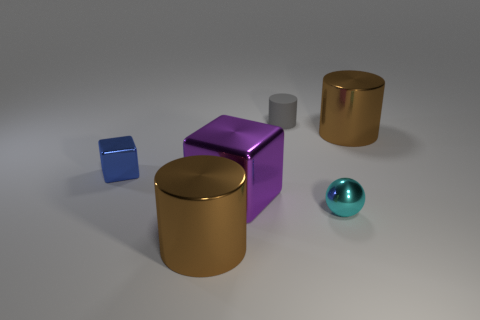Add 3 blue blocks. How many objects exist? 9 Subtract all tiny cylinders. How many cylinders are left? 2 Subtract 1 cubes. How many cubes are left? 1 Subtract all gray cylinders. How many cylinders are left? 2 Subtract all balls. How many objects are left? 5 Add 6 tiny gray shiny objects. How many tiny gray shiny objects exist? 6 Subtract 1 cyan balls. How many objects are left? 5 Subtract all brown spheres. Subtract all red cylinders. How many spheres are left? 1 Subtract all cyan cubes. How many purple spheres are left? 0 Subtract all large purple blocks. Subtract all blue cylinders. How many objects are left? 5 